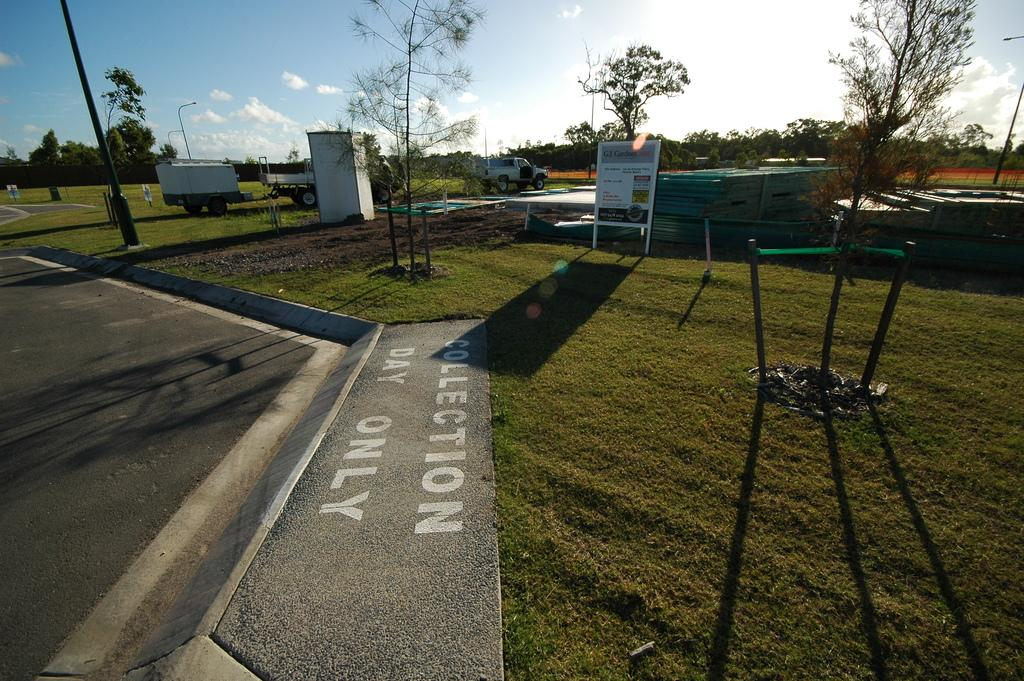What is located on the left side of the image? There is a road on the left side of the image. What type of landscape is on the right side of the image? There is grassland on the right side of the image. What can be seen in the background of the image? There are trees and trucks in the background of the image. What is visible at the top of the image? The sky is visible in the image, and clouds are present in the sky. What type of soda is being poured into the grassland in the image? There is no soda present in the image, and no liquid is being poured into the grassland. Can you tell me how many sons are visible in the image? There are no people, let alone sons, visible in the image. 